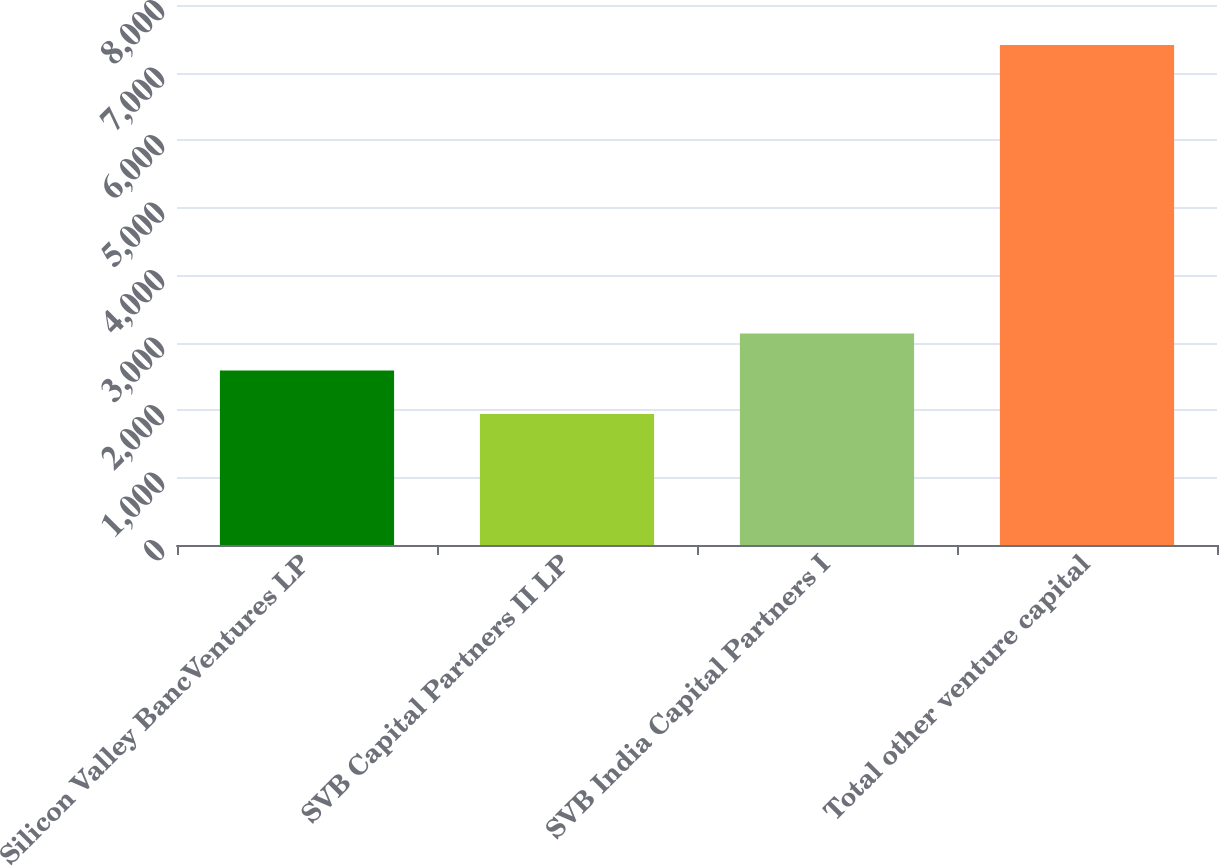<chart> <loc_0><loc_0><loc_500><loc_500><bar_chart><fcel>Silicon Valley BancVentures LP<fcel>SVB Capital Partners II LP<fcel>SVB India Capital Partners I<fcel>Total other venture capital<nl><fcel>2587<fcel>1942<fcel>3133.7<fcel>7409<nl></chart> 